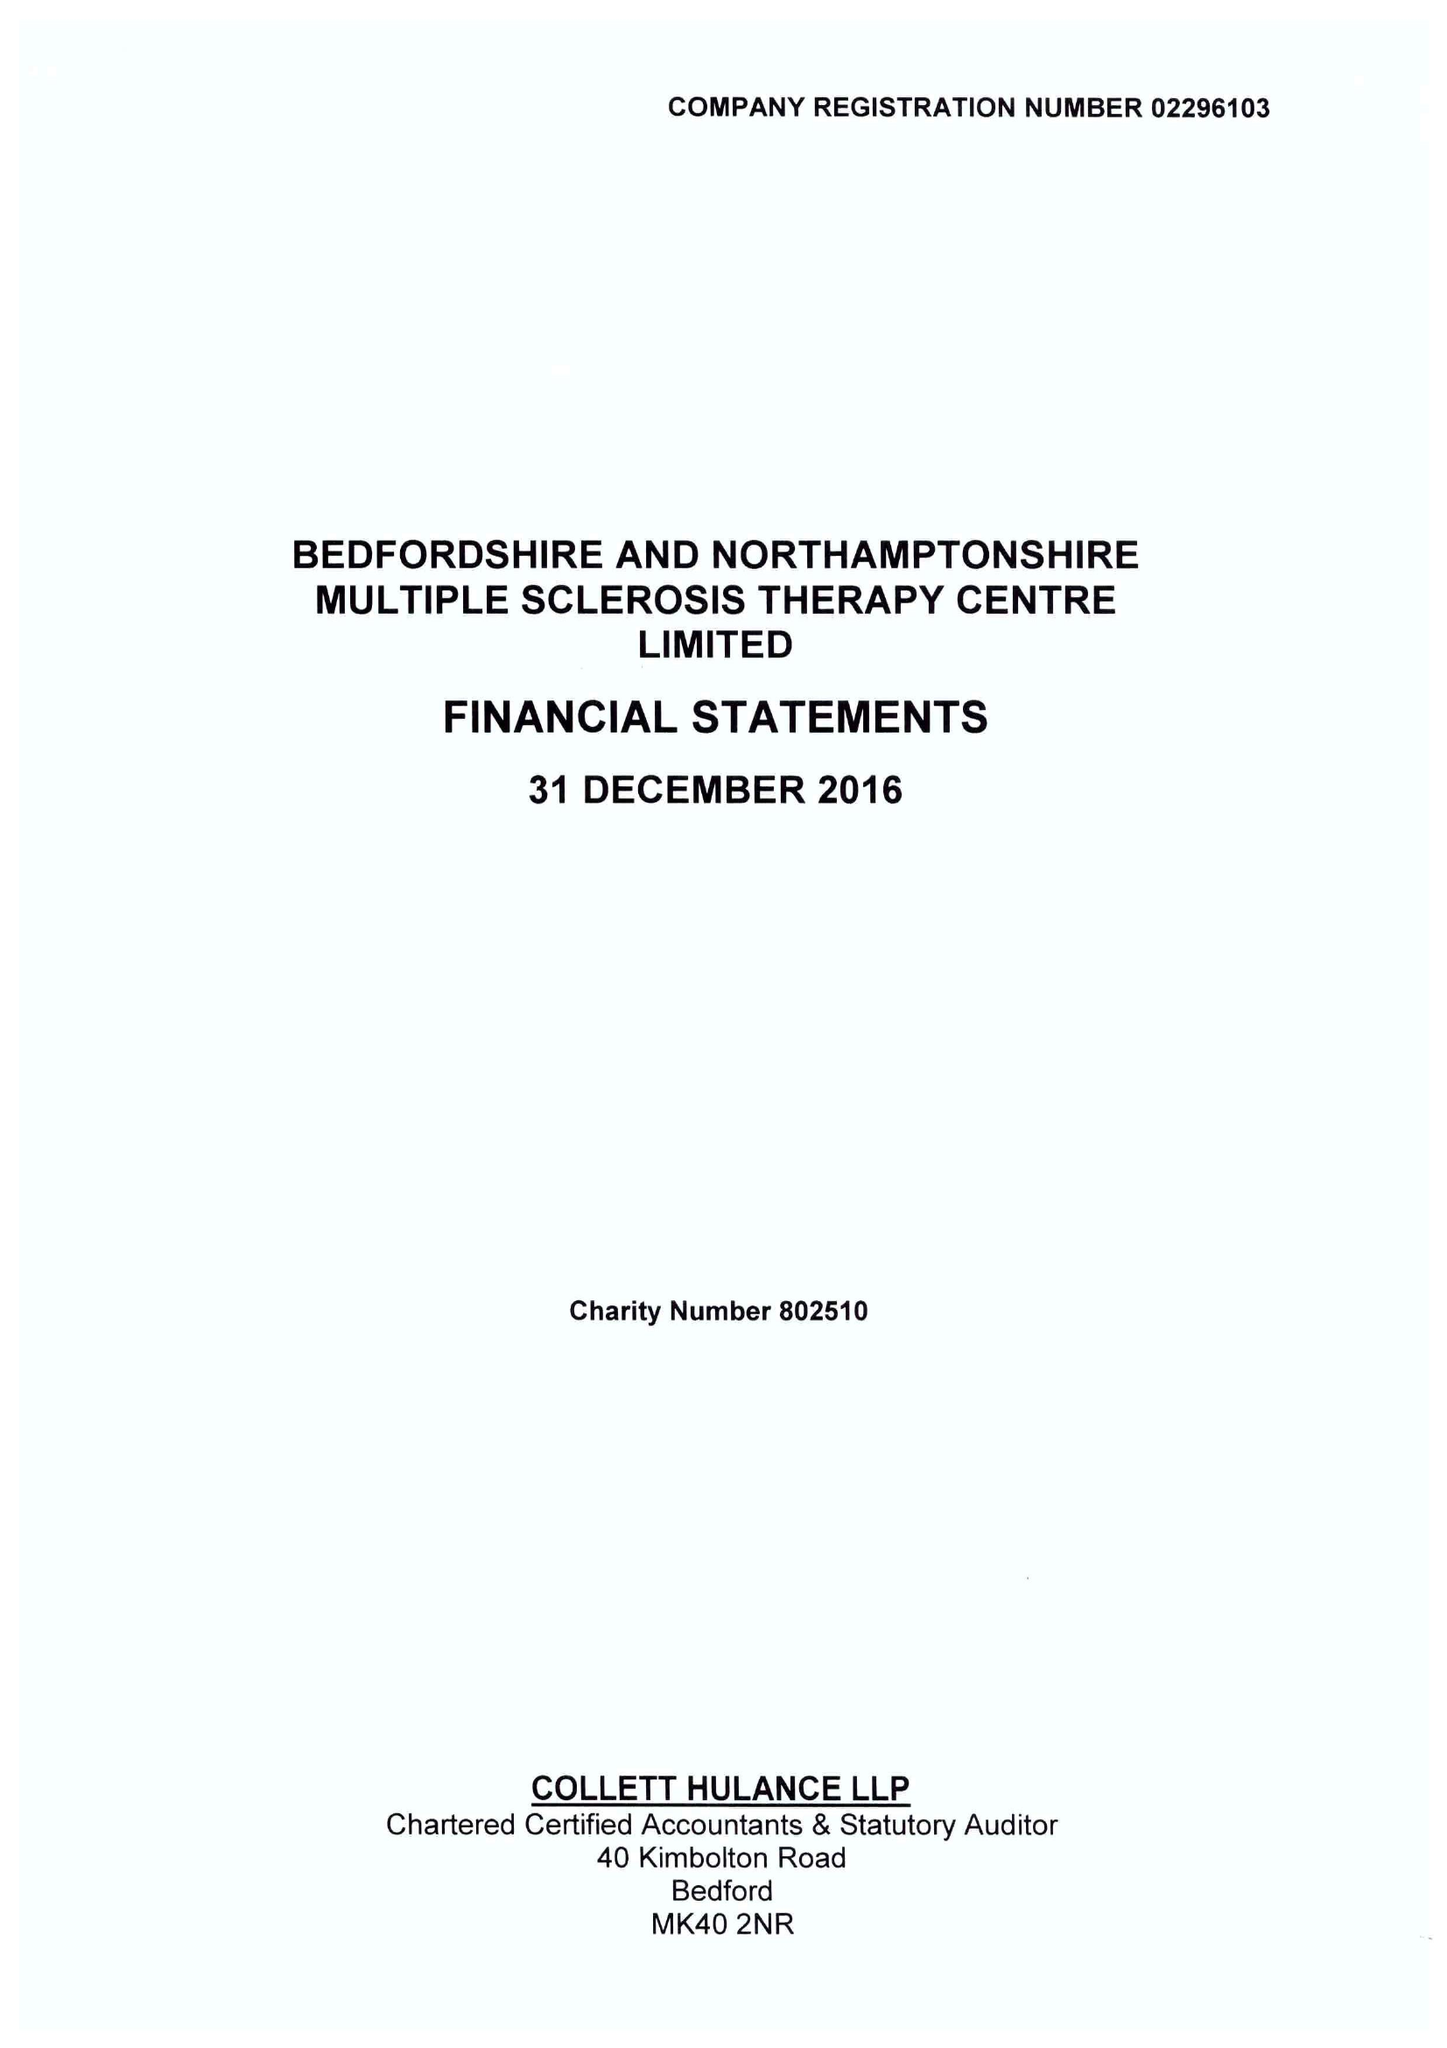What is the value for the address__street_line?
Answer the question using a single word or phrase. BARKERS LANE 